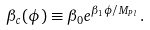Convert formula to latex. <formula><loc_0><loc_0><loc_500><loc_500>\beta _ { c } ( \phi ) \equiv \beta _ { 0 } e ^ { \beta _ { 1 } \phi / M _ { P l } } \, .</formula> 